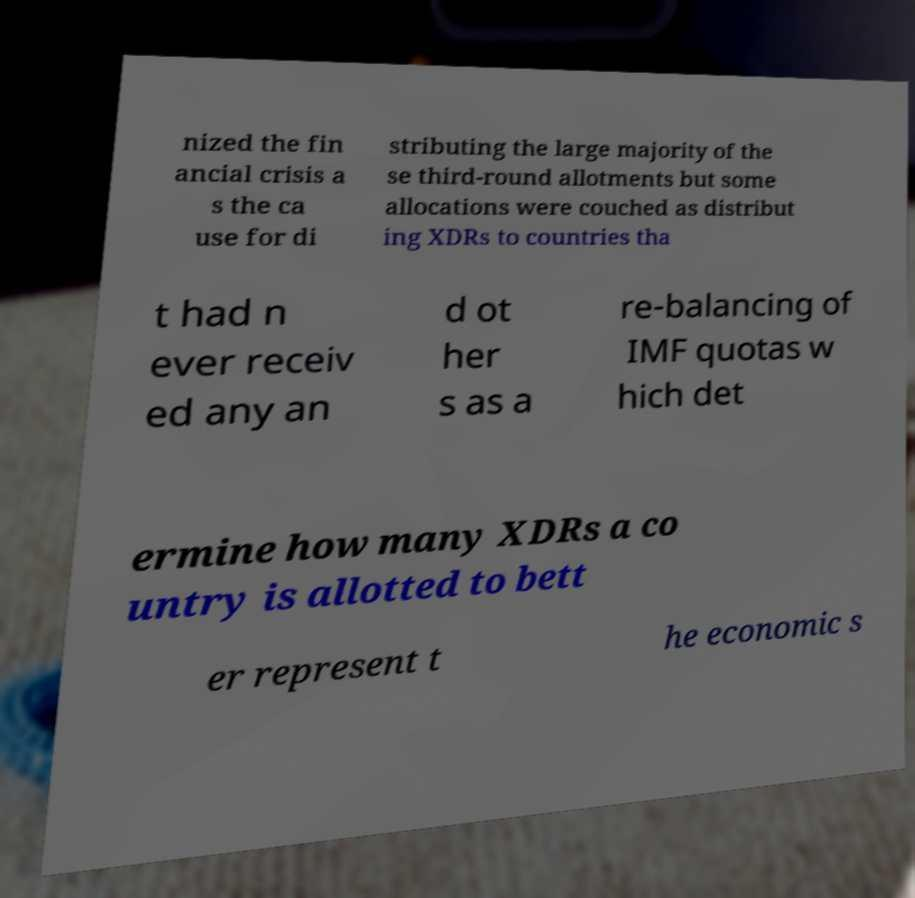For documentation purposes, I need the text within this image transcribed. Could you provide that? nized the fin ancial crisis a s the ca use for di stributing the large majority of the se third-round allotments but some allocations were couched as distribut ing XDRs to countries tha t had n ever receiv ed any an d ot her s as a re-balancing of IMF quotas w hich det ermine how many XDRs a co untry is allotted to bett er represent t he economic s 